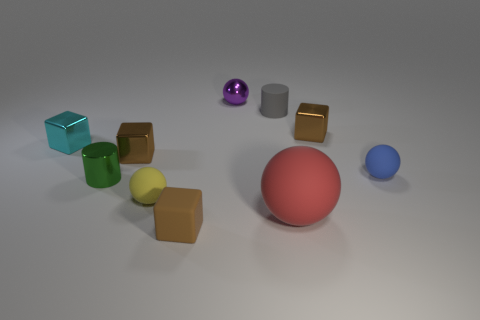Subtract all brown blocks. How many were subtracted if there are1brown blocks left? 2 Subtract all yellow balls. How many brown cubes are left? 3 Subtract all small brown rubber blocks. How many blocks are left? 3 Subtract 2 balls. How many balls are left? 2 Subtract all gray cylinders. How many cylinders are left? 1 Subtract all balls. How many objects are left? 6 Subtract 0 gray spheres. How many objects are left? 10 Subtract all cyan blocks. Subtract all cyan cylinders. How many blocks are left? 3 Subtract all big blue cylinders. Subtract all small yellow rubber spheres. How many objects are left? 9 Add 2 tiny blue matte things. How many tiny blue matte things are left? 3 